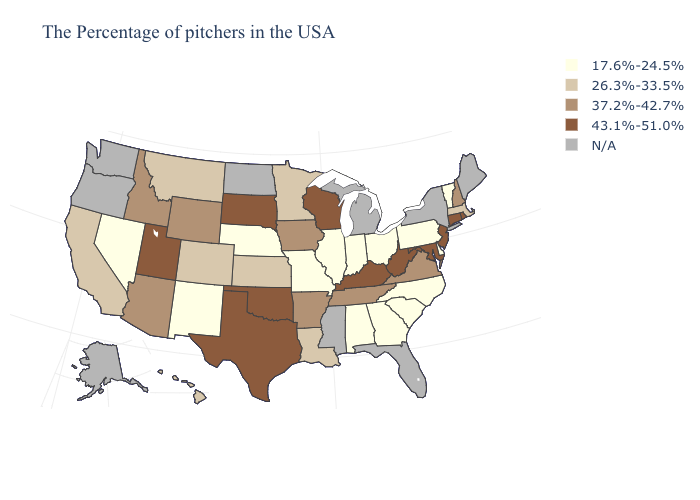What is the value of Alabama?
Be succinct. 17.6%-24.5%. Name the states that have a value in the range 43.1%-51.0%?
Short answer required. Rhode Island, Connecticut, New Jersey, Maryland, West Virginia, Kentucky, Wisconsin, Oklahoma, Texas, South Dakota, Utah. Does Iowa have the lowest value in the MidWest?
Answer briefly. No. Among the states that border Minnesota , does Wisconsin have the highest value?
Give a very brief answer. Yes. How many symbols are there in the legend?
Short answer required. 5. Which states have the lowest value in the South?
Answer briefly. Delaware, North Carolina, South Carolina, Georgia, Alabama. What is the highest value in states that border Wisconsin?
Keep it brief. 37.2%-42.7%. What is the value of Rhode Island?
Be succinct. 43.1%-51.0%. Which states have the highest value in the USA?
Quick response, please. Rhode Island, Connecticut, New Jersey, Maryland, West Virginia, Kentucky, Wisconsin, Oklahoma, Texas, South Dakota, Utah. Name the states that have a value in the range 37.2%-42.7%?
Concise answer only. New Hampshire, Virginia, Tennessee, Arkansas, Iowa, Wyoming, Arizona, Idaho. What is the value of Montana?
Answer briefly. 26.3%-33.5%. Name the states that have a value in the range 37.2%-42.7%?
Be succinct. New Hampshire, Virginia, Tennessee, Arkansas, Iowa, Wyoming, Arizona, Idaho. Name the states that have a value in the range 17.6%-24.5%?
Keep it brief. Vermont, Delaware, Pennsylvania, North Carolina, South Carolina, Ohio, Georgia, Indiana, Alabama, Illinois, Missouri, Nebraska, New Mexico, Nevada. Which states have the lowest value in the South?
Short answer required. Delaware, North Carolina, South Carolina, Georgia, Alabama. 